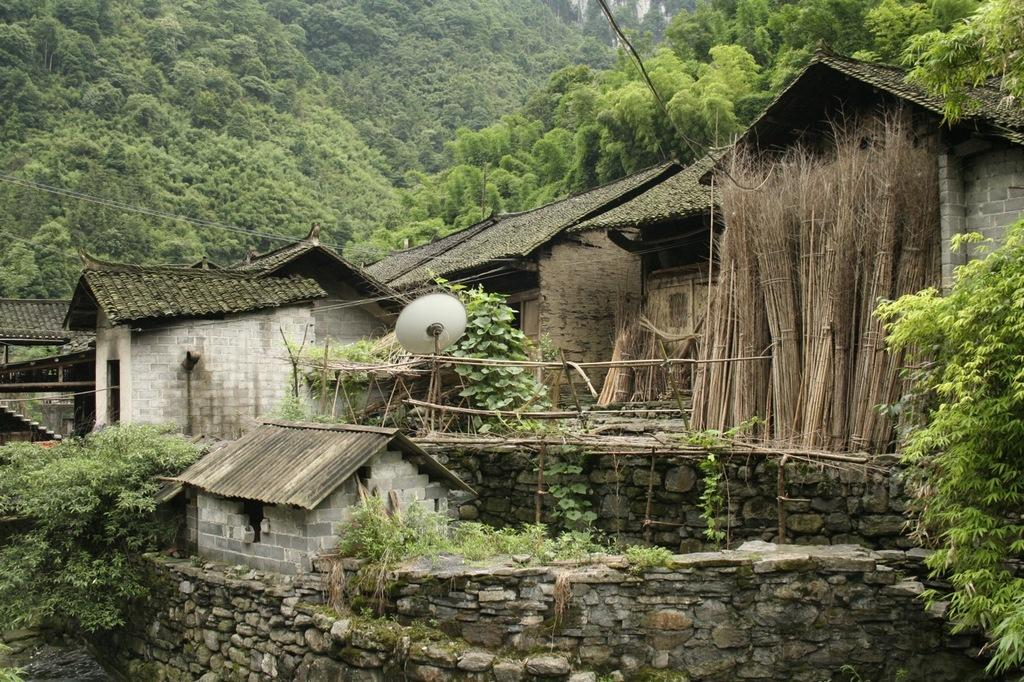What type of structures can be seen in the image? There are houses in the image. What other elements are present in the image besides the houses? There are plants, a fence, a dish antenna, and trees in the image. What type of reaction does the aunt have when she sees the beds in the image? There are no beds or aunts present in the image, so it is not possible to determine any reactions. 